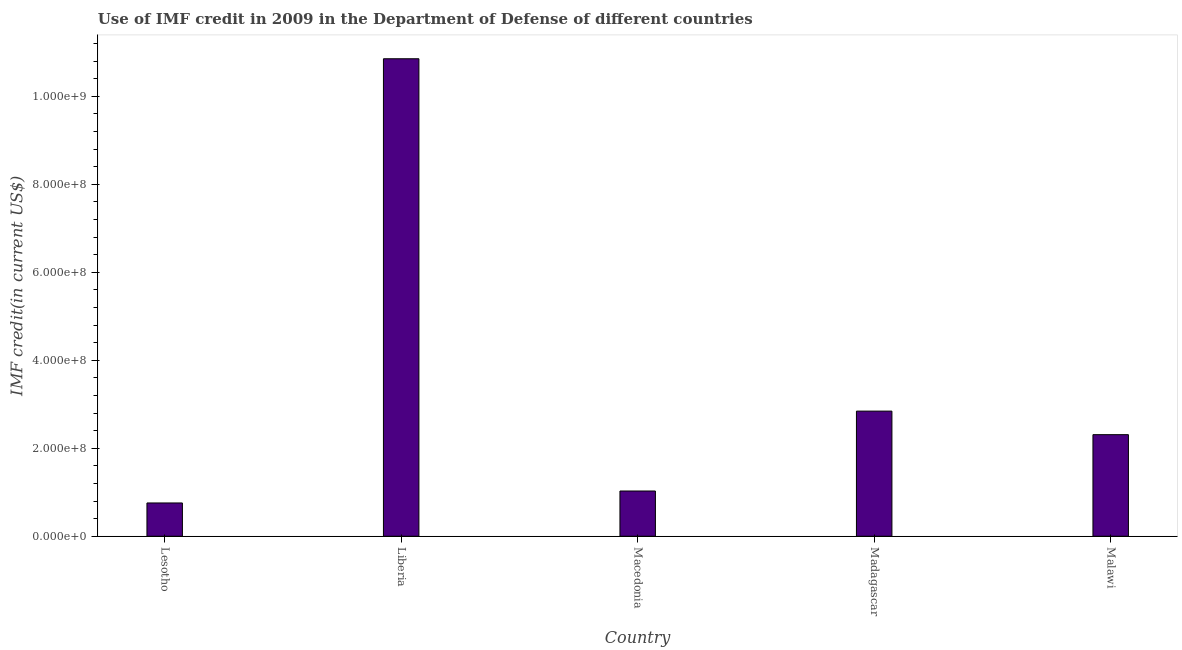Does the graph contain any zero values?
Your response must be concise. No. What is the title of the graph?
Keep it short and to the point. Use of IMF credit in 2009 in the Department of Defense of different countries. What is the label or title of the Y-axis?
Provide a short and direct response. IMF credit(in current US$). What is the use of imf credit in dod in Malawi?
Keep it short and to the point. 2.31e+08. Across all countries, what is the maximum use of imf credit in dod?
Make the answer very short. 1.09e+09. Across all countries, what is the minimum use of imf credit in dod?
Your answer should be compact. 7.57e+07. In which country was the use of imf credit in dod maximum?
Ensure brevity in your answer.  Liberia. In which country was the use of imf credit in dod minimum?
Offer a terse response. Lesotho. What is the sum of the use of imf credit in dod?
Your answer should be compact. 1.78e+09. What is the difference between the use of imf credit in dod in Lesotho and Macedonia?
Your answer should be compact. -2.72e+07. What is the average use of imf credit in dod per country?
Provide a short and direct response. 3.56e+08. What is the median use of imf credit in dod?
Your answer should be very brief. 2.31e+08. What is the ratio of the use of imf credit in dod in Lesotho to that in Liberia?
Your answer should be compact. 0.07. Is the use of imf credit in dod in Lesotho less than that in Malawi?
Offer a very short reply. Yes. What is the difference between the highest and the second highest use of imf credit in dod?
Provide a succinct answer. 8.01e+08. Is the sum of the use of imf credit in dod in Lesotho and Malawi greater than the maximum use of imf credit in dod across all countries?
Provide a succinct answer. No. What is the difference between the highest and the lowest use of imf credit in dod?
Your answer should be very brief. 1.01e+09. In how many countries, is the use of imf credit in dod greater than the average use of imf credit in dod taken over all countries?
Give a very brief answer. 1. How many countries are there in the graph?
Offer a terse response. 5. What is the difference between two consecutive major ticks on the Y-axis?
Ensure brevity in your answer.  2.00e+08. Are the values on the major ticks of Y-axis written in scientific E-notation?
Offer a terse response. Yes. What is the IMF credit(in current US$) of Lesotho?
Provide a succinct answer. 7.57e+07. What is the IMF credit(in current US$) in Liberia?
Your response must be concise. 1.09e+09. What is the IMF credit(in current US$) of Macedonia?
Your response must be concise. 1.03e+08. What is the IMF credit(in current US$) of Madagascar?
Your answer should be very brief. 2.84e+08. What is the IMF credit(in current US$) of Malawi?
Offer a terse response. 2.31e+08. What is the difference between the IMF credit(in current US$) in Lesotho and Liberia?
Offer a very short reply. -1.01e+09. What is the difference between the IMF credit(in current US$) in Lesotho and Macedonia?
Your answer should be very brief. -2.72e+07. What is the difference between the IMF credit(in current US$) in Lesotho and Madagascar?
Your answer should be compact. -2.09e+08. What is the difference between the IMF credit(in current US$) in Lesotho and Malawi?
Ensure brevity in your answer.  -1.55e+08. What is the difference between the IMF credit(in current US$) in Liberia and Macedonia?
Provide a short and direct response. 9.83e+08. What is the difference between the IMF credit(in current US$) in Liberia and Madagascar?
Your answer should be compact. 8.01e+08. What is the difference between the IMF credit(in current US$) in Liberia and Malawi?
Give a very brief answer. 8.55e+08. What is the difference between the IMF credit(in current US$) in Macedonia and Madagascar?
Ensure brevity in your answer.  -1.82e+08. What is the difference between the IMF credit(in current US$) in Macedonia and Malawi?
Your answer should be very brief. -1.28e+08. What is the difference between the IMF credit(in current US$) in Madagascar and Malawi?
Give a very brief answer. 5.35e+07. What is the ratio of the IMF credit(in current US$) in Lesotho to that in Liberia?
Your answer should be compact. 0.07. What is the ratio of the IMF credit(in current US$) in Lesotho to that in Macedonia?
Your answer should be compact. 0.74. What is the ratio of the IMF credit(in current US$) in Lesotho to that in Madagascar?
Your response must be concise. 0.27. What is the ratio of the IMF credit(in current US$) in Lesotho to that in Malawi?
Offer a terse response. 0.33. What is the ratio of the IMF credit(in current US$) in Liberia to that in Macedonia?
Ensure brevity in your answer.  10.55. What is the ratio of the IMF credit(in current US$) in Liberia to that in Madagascar?
Offer a very short reply. 3.82. What is the ratio of the IMF credit(in current US$) in Macedonia to that in Madagascar?
Give a very brief answer. 0.36. What is the ratio of the IMF credit(in current US$) in Macedonia to that in Malawi?
Provide a short and direct response. 0.45. What is the ratio of the IMF credit(in current US$) in Madagascar to that in Malawi?
Provide a short and direct response. 1.23. 